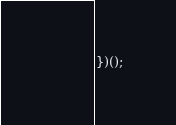<code> <loc_0><loc_0><loc_500><loc_500><_JavaScript_>})();
</code> 